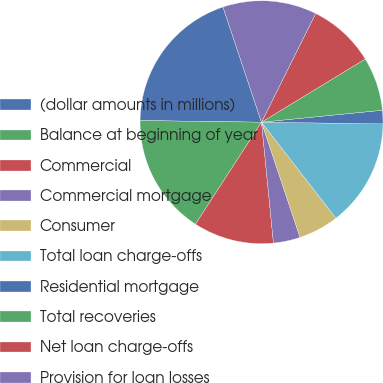Convert chart. <chart><loc_0><loc_0><loc_500><loc_500><pie_chart><fcel>(dollar amounts in millions)<fcel>Balance at beginning of year<fcel>Commercial<fcel>Commercial mortgage<fcel>Consumer<fcel>Total loan charge-offs<fcel>Residential mortgage<fcel>Total recoveries<fcel>Net loan charge-offs<fcel>Provision for loan losses<nl><fcel>19.64%<fcel>16.07%<fcel>10.71%<fcel>3.57%<fcel>5.36%<fcel>14.28%<fcel>1.79%<fcel>7.14%<fcel>8.93%<fcel>12.5%<nl></chart> 